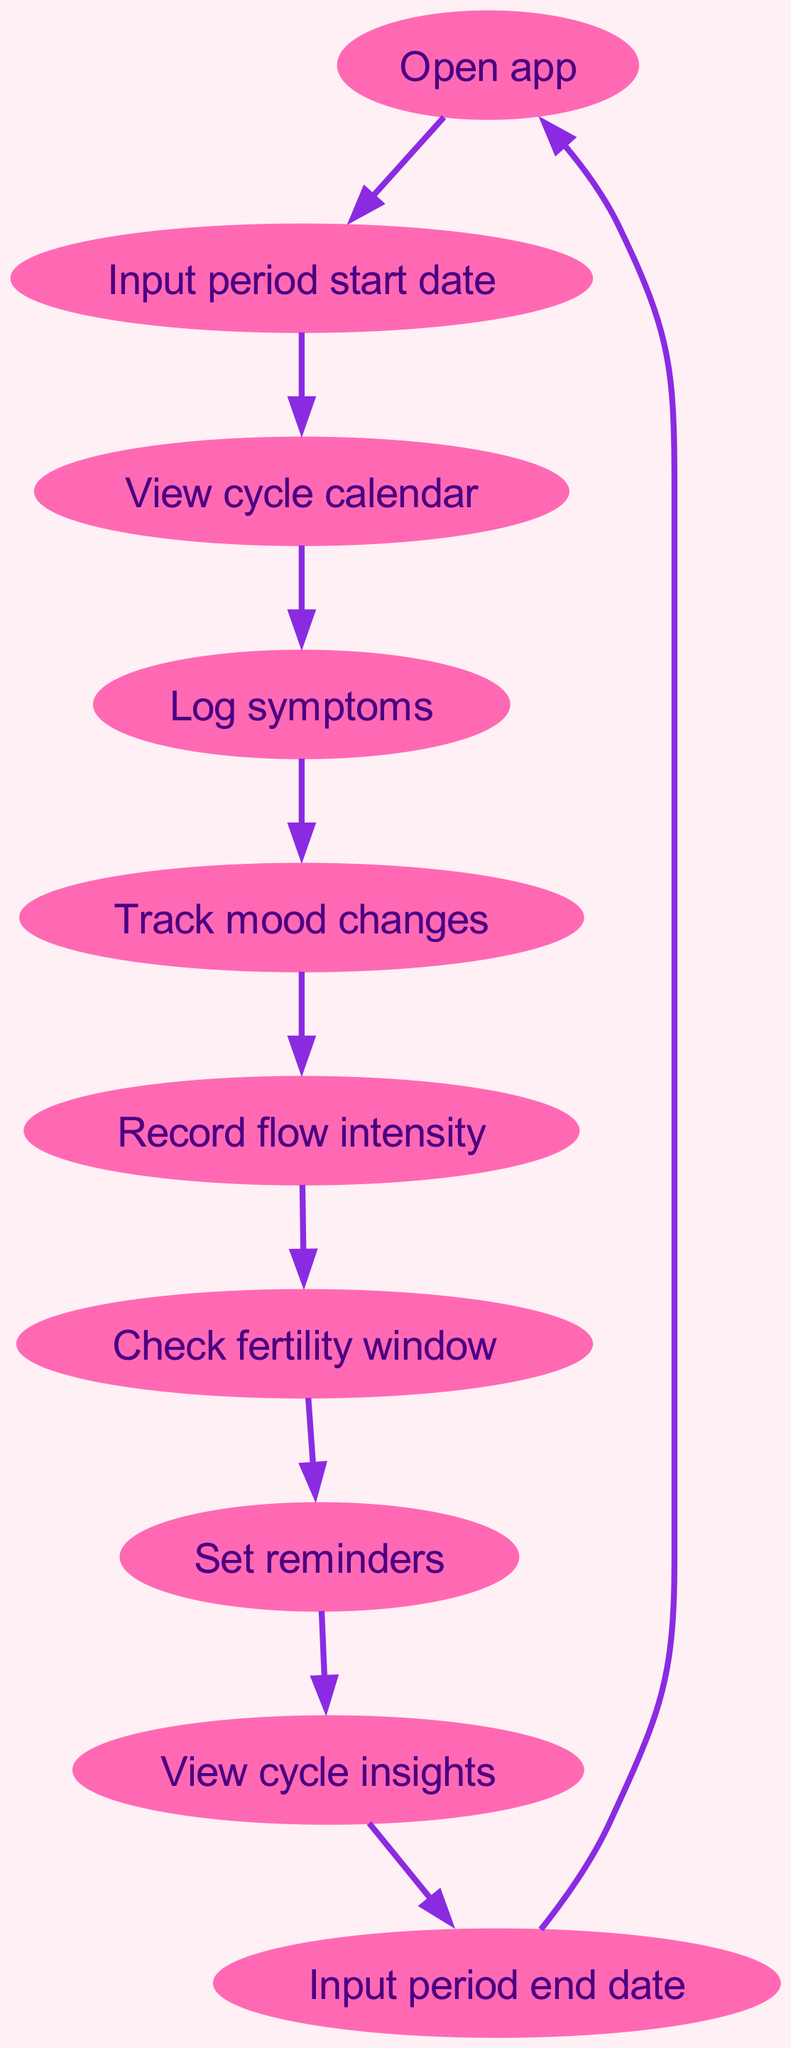What is the total number of nodes in the diagram? The diagram lists 10 distinct activities (nodes) that a user can interact with in the app during their menstrual cycle journey. This can be counted directly from the 'nodes' section of the data.
Answer: 10 Which node comes directly after recording flow intensity? By examining the directed edges in the diagram, we can see that the node that follows 'Record flow intensity' is 'Check fertility window.' This information can be found by looking at the edge that starts from 'Record flow intensity.'
Answer: Check fertility window What node is the starting point for the journey in the app? The journey starts at the 'Open app' node, which is indicated as the first activity users perform when they begin using the app. This is derived from the first edge in the connection flow.
Answer: Open app How many edges are there in the diagram? The diagram contains 10 edges, each representing a directed interaction between two nodes. This is determined by counting the connections in the 'edges' section of the data.
Answer: 10 What is the final action before starting the process again? The final action shown in the diagram before returning to the start is 'Input period end date,' as it loops the user back to 'Open app.' This is identified by the last edge connecting these two nodes.
Answer: Input period end date Which two nodes connect the 'Set reminders' activity? The nodes that directly connect to 'Set reminders' are 'Check fertility window' leading into 'Set reminders' and 'Set reminders' leading into 'View cycle insights.' This involves following both incoming and outgoing edges.
Answer: Check fertility window and View cycle insights What is the sequence of nodes from mood tracking to flow intensity recording? The sequence is 'Track mood changes' leading to 'Record flow intensity,' indicating the progression in the app between these two activities. This can be seen through the flow of directed edges in the diagram.
Answer: Track mood changes to Record flow intensity Identify a node that does not lead to another node. The node 'Input period end date' does not lead to any subsequent node, as the flow from there returns to 'Open app.' This is noted by observing that there are no edges directed away from it.
Answer: Input period end date What is the overall flow of activities starting from the calendar view? The flow starts at 'View cycle calendar,' transitions to 'Log symptoms,' then 'Track mood changes,' 'Record flow intensity,' 'Check fertility window,' 'Set reminders,' and finishing with 'View cycle insights.' This outline follows the connecting edges starting from the specified node.
Answer: Log symptoms, Track mood changes, Record flow intensity, Check fertility window, Set reminders, View cycle insights 